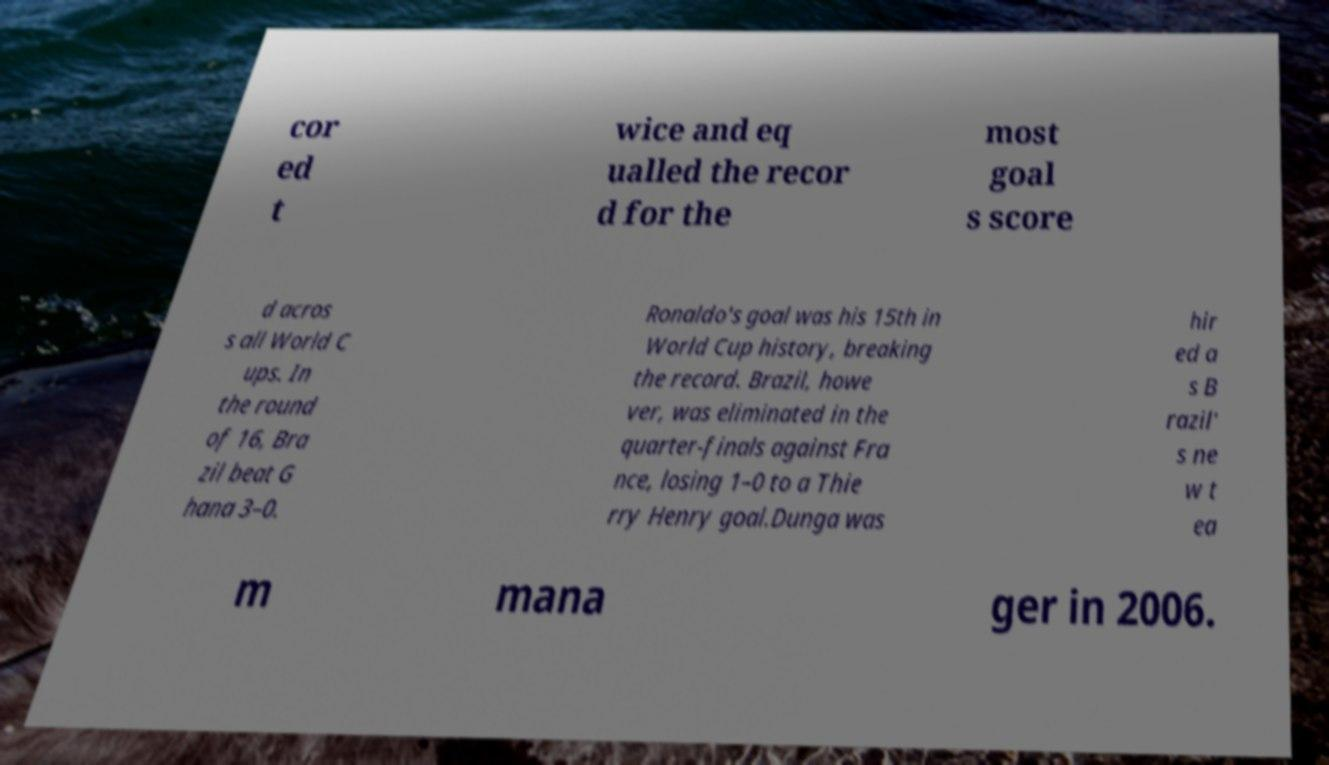For documentation purposes, I need the text within this image transcribed. Could you provide that? cor ed t wice and eq ualled the recor d for the most goal s score d acros s all World C ups. In the round of 16, Bra zil beat G hana 3–0. Ronaldo's goal was his 15th in World Cup history, breaking the record. Brazil, howe ver, was eliminated in the quarter-finals against Fra nce, losing 1–0 to a Thie rry Henry goal.Dunga was hir ed a s B razil' s ne w t ea m mana ger in 2006. 